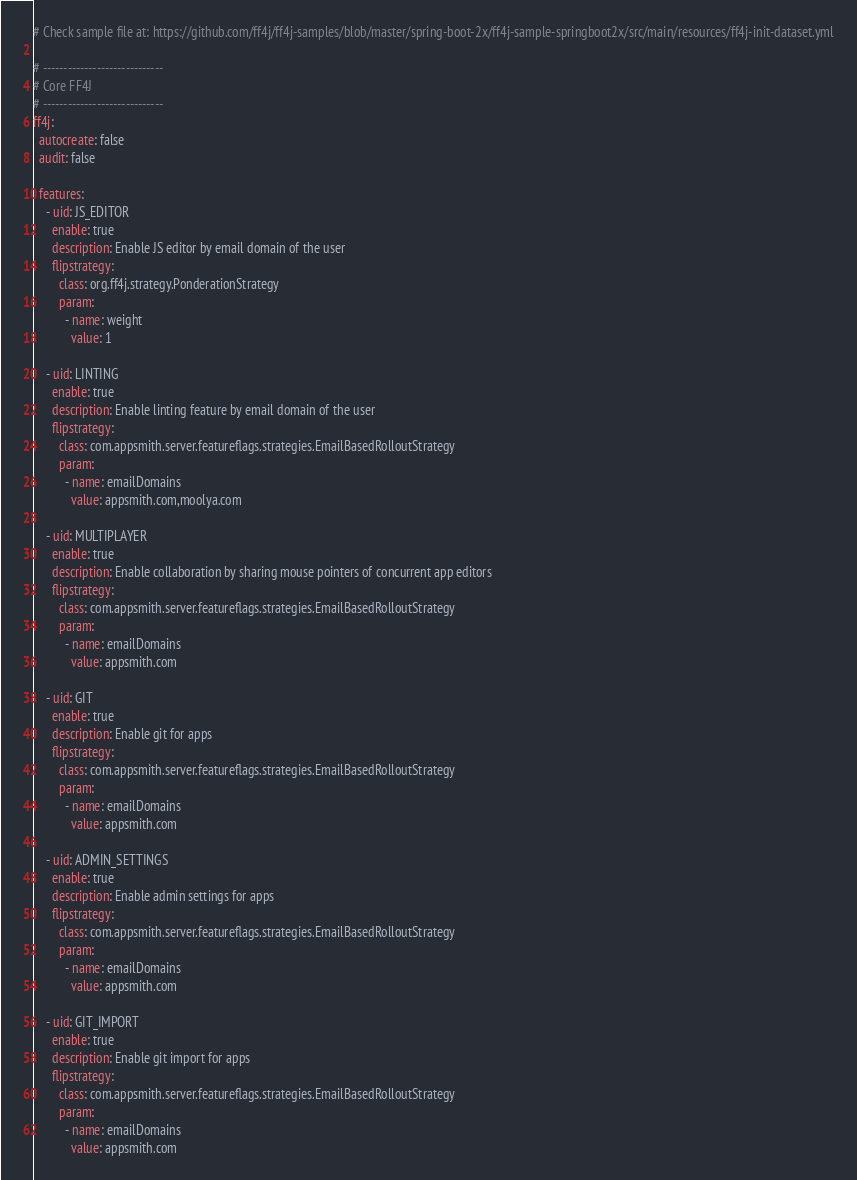Convert code to text. <code><loc_0><loc_0><loc_500><loc_500><_YAML_># Check sample file at: https://github.com/ff4j/ff4j-samples/blob/master/spring-boot-2x/ff4j-sample-springboot2x/src/main/resources/ff4j-init-dataset.yml

# -----------------------------
# Core FF4J
# -----------------------------
ff4j:
  autocreate: false
  audit: false

  features:
    - uid: JS_EDITOR
      enable: true
      description: Enable JS editor by email domain of the user
      flipstrategy:
        class: org.ff4j.strategy.PonderationStrategy
        param:
          - name: weight
            value: 1

    - uid: LINTING
      enable: true
      description: Enable linting feature by email domain of the user
      flipstrategy:
        class: com.appsmith.server.featureflags.strategies.EmailBasedRolloutStrategy
        param:
          - name: emailDomains
            value: appsmith.com,moolya.com

    - uid: MULTIPLAYER
      enable: true
      description: Enable collaboration by sharing mouse pointers of concurrent app editors
      flipstrategy:
        class: com.appsmith.server.featureflags.strategies.EmailBasedRolloutStrategy
        param:
          - name: emailDomains
            value: appsmith.com

    - uid: GIT
      enable: true
      description: Enable git for apps
      flipstrategy:
        class: com.appsmith.server.featureflags.strategies.EmailBasedRolloutStrategy
        param:
          - name: emailDomains
            value: appsmith.com

    - uid: ADMIN_SETTINGS
      enable: true
      description: Enable admin settings for apps
      flipstrategy:
        class: com.appsmith.server.featureflags.strategies.EmailBasedRolloutStrategy
        param:
          - name: emailDomains
            value: appsmith.com
    
    - uid: GIT_IMPORT
      enable: true
      description: Enable git import for apps
      flipstrategy:
        class: com.appsmith.server.featureflags.strategies.EmailBasedRolloutStrategy
        param:
          - name: emailDomains
            value: appsmith.com
</code> 